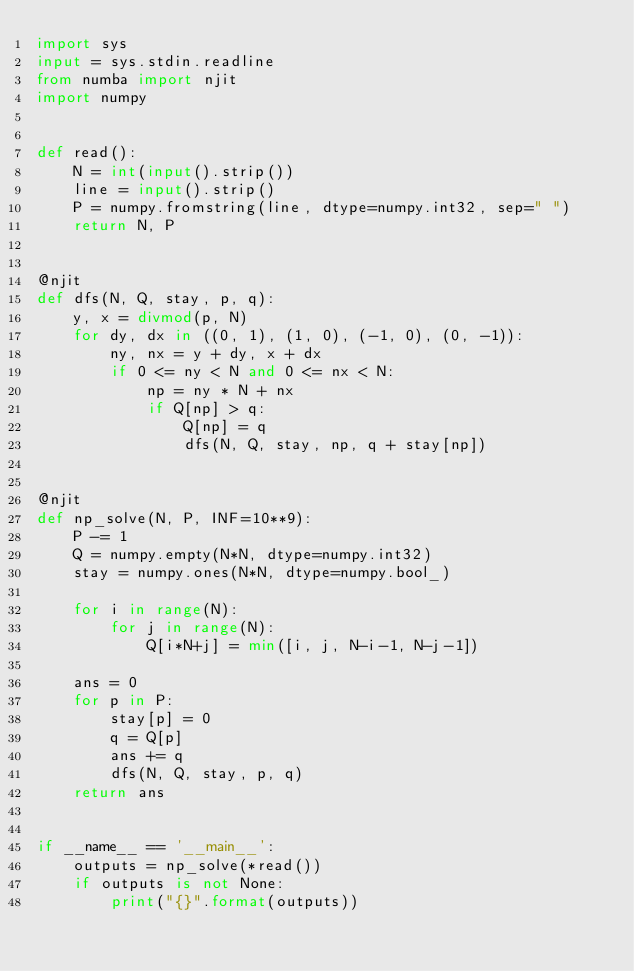Convert code to text. <code><loc_0><loc_0><loc_500><loc_500><_Python_>import sys
input = sys.stdin.readline
from numba import njit
import numpy


def read():
    N = int(input().strip())
    line = input().strip()
    P = numpy.fromstring(line, dtype=numpy.int32, sep=" ")
    return N, P


@njit
def dfs(N, Q, stay, p, q):
    y, x = divmod(p, N)
    for dy, dx in ((0, 1), (1, 0), (-1, 0), (0, -1)):
        ny, nx = y + dy, x + dx
        if 0 <= ny < N and 0 <= nx < N:
            np = ny * N + nx
            if Q[np] > q:
                Q[np] = q
                dfs(N, Q, stay, np, q + stay[np])


@njit
def np_solve(N, P, INF=10**9):
    P -= 1
    Q = numpy.empty(N*N, dtype=numpy.int32)
    stay = numpy.ones(N*N, dtype=numpy.bool_)
    
    for i in range(N):
        for j in range(N):
            Q[i*N+j] = min([i, j, N-i-1, N-j-1])

    ans = 0
    for p in P:
        stay[p] = 0
        q = Q[p]
        ans += q
        dfs(N, Q, stay, p, q)
    return ans


if __name__ == '__main__':
    outputs = np_solve(*read())
    if outputs is not None:
        print("{}".format(outputs))
</code> 